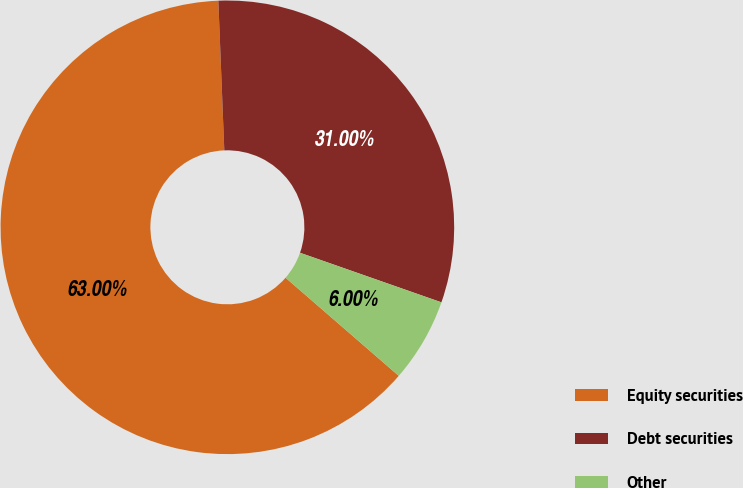Convert chart to OTSL. <chart><loc_0><loc_0><loc_500><loc_500><pie_chart><fcel>Equity securities<fcel>Debt securities<fcel>Other<nl><fcel>63.0%<fcel>31.0%<fcel>6.0%<nl></chart> 